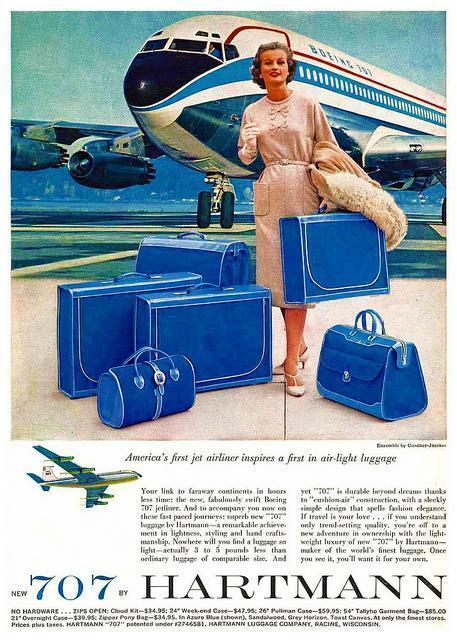How many bags are shown?
Give a very brief answer. 6. How many suitcases are there?
Give a very brief answer. 6. 